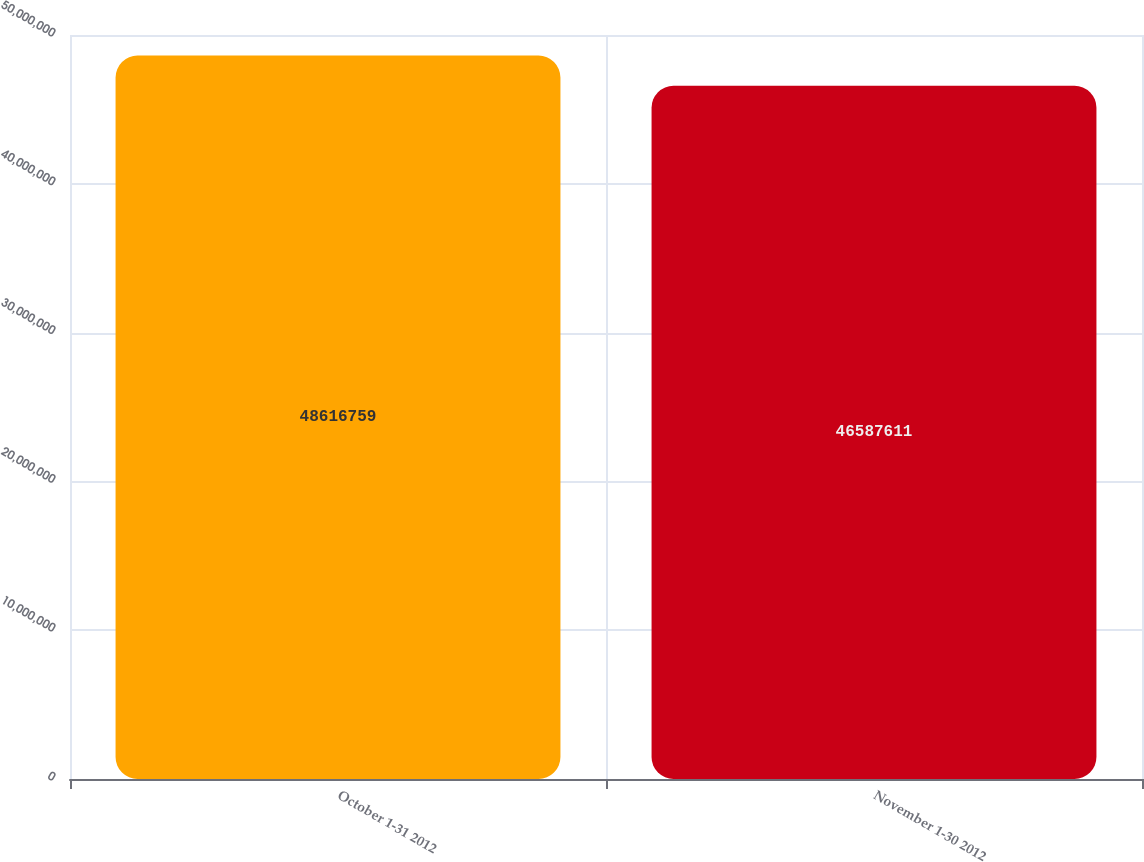<chart> <loc_0><loc_0><loc_500><loc_500><bar_chart><fcel>October 1-31 2012<fcel>November 1-30 2012<nl><fcel>4.86168e+07<fcel>4.65876e+07<nl></chart> 